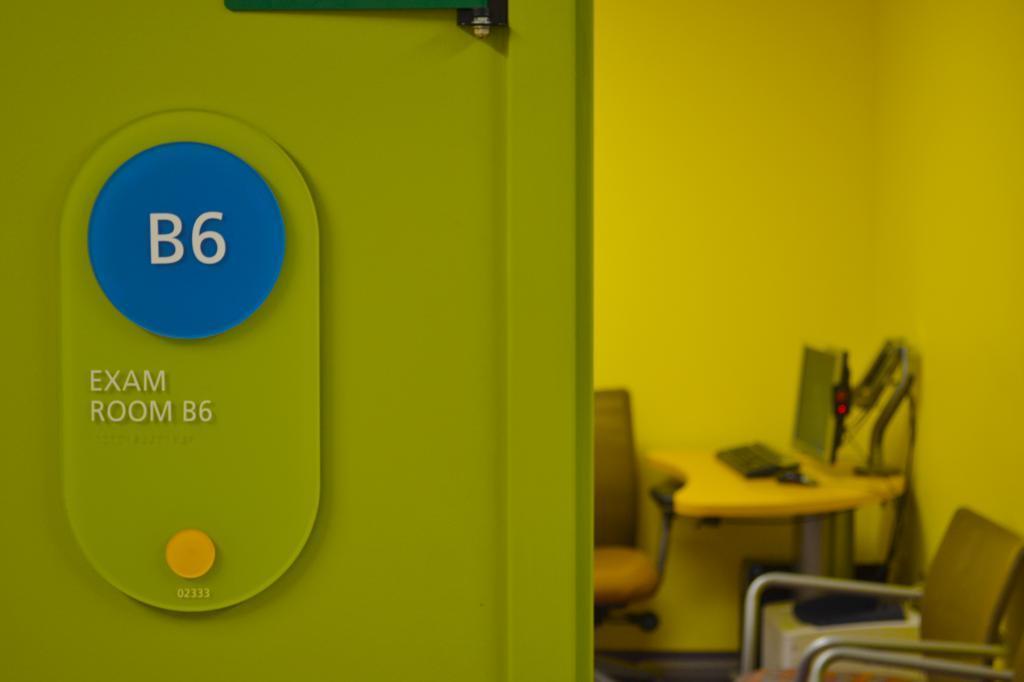Could you give a brief overview of what you see in this image? In this image I can see green colour thing and on it I can see something is written. In the background I can see few chairs, a table and on this table I can see a monitor and a keyboard. I can also see this image is little bit blurry from background. 